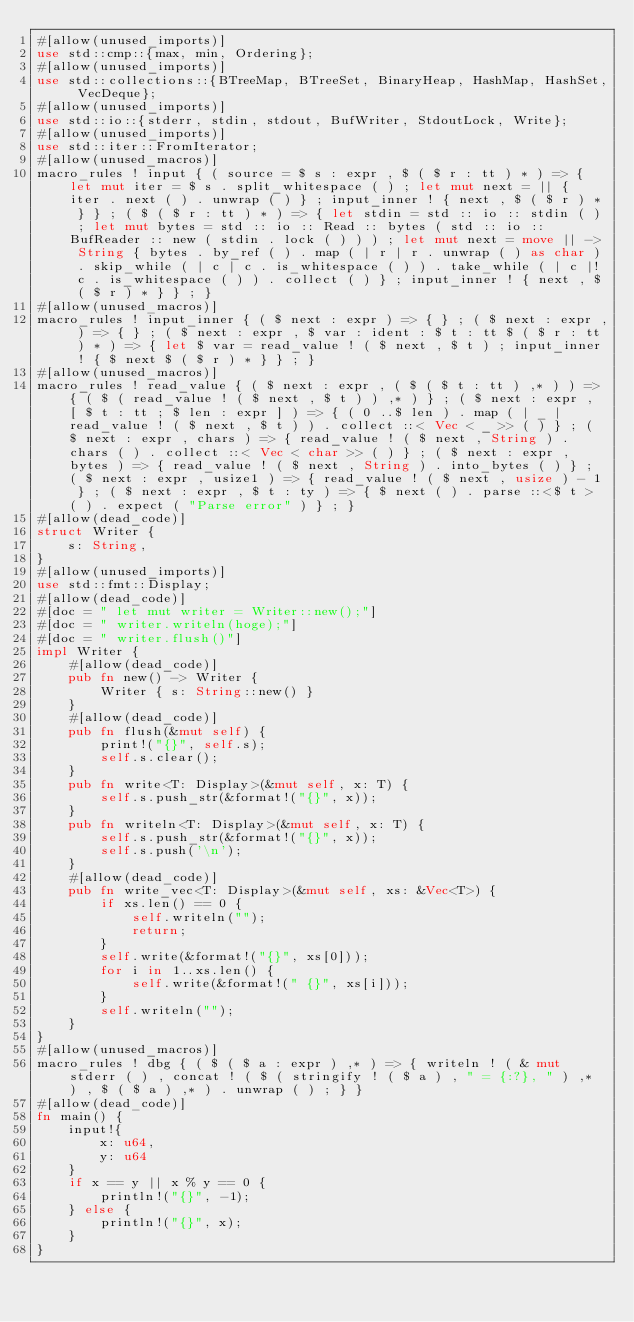<code> <loc_0><loc_0><loc_500><loc_500><_Rust_>#[allow(unused_imports)]
use std::cmp::{max, min, Ordering};
#[allow(unused_imports)]
use std::collections::{BTreeMap, BTreeSet, BinaryHeap, HashMap, HashSet, VecDeque};
#[allow(unused_imports)]
use std::io::{stderr, stdin, stdout, BufWriter, StdoutLock, Write};
#[allow(unused_imports)]
use std::iter::FromIterator;
#[allow(unused_macros)]
macro_rules ! input { ( source = $ s : expr , $ ( $ r : tt ) * ) => { let mut iter = $ s . split_whitespace ( ) ; let mut next = || { iter . next ( ) . unwrap ( ) } ; input_inner ! { next , $ ( $ r ) * } } ; ( $ ( $ r : tt ) * ) => { let stdin = std :: io :: stdin ( ) ; let mut bytes = std :: io :: Read :: bytes ( std :: io :: BufReader :: new ( stdin . lock ( ) ) ) ; let mut next = move || -> String { bytes . by_ref ( ) . map ( | r | r . unwrap ( ) as char ) . skip_while ( | c | c . is_whitespace ( ) ) . take_while ( | c |! c . is_whitespace ( ) ) . collect ( ) } ; input_inner ! { next , $ ( $ r ) * } } ; }
#[allow(unused_macros)]
macro_rules ! input_inner { ( $ next : expr ) => { } ; ( $ next : expr , ) => { } ; ( $ next : expr , $ var : ident : $ t : tt $ ( $ r : tt ) * ) => { let $ var = read_value ! ( $ next , $ t ) ; input_inner ! { $ next $ ( $ r ) * } } ; }
#[allow(unused_macros)]
macro_rules ! read_value { ( $ next : expr , ( $ ( $ t : tt ) ,* ) ) => { ( $ ( read_value ! ( $ next , $ t ) ) ,* ) } ; ( $ next : expr , [ $ t : tt ; $ len : expr ] ) => { ( 0 ..$ len ) . map ( | _ | read_value ! ( $ next , $ t ) ) . collect ::< Vec < _ >> ( ) } ; ( $ next : expr , chars ) => { read_value ! ( $ next , String ) . chars ( ) . collect ::< Vec < char >> ( ) } ; ( $ next : expr , bytes ) => { read_value ! ( $ next , String ) . into_bytes ( ) } ; ( $ next : expr , usize1 ) => { read_value ! ( $ next , usize ) - 1 } ; ( $ next : expr , $ t : ty ) => { $ next ( ) . parse ::<$ t > ( ) . expect ( "Parse error" ) } ; }
#[allow(dead_code)]
struct Writer {
    s: String,
}
#[allow(unused_imports)]
use std::fmt::Display;
#[allow(dead_code)]
#[doc = " let mut writer = Writer::new();"]
#[doc = " writer.writeln(hoge);"]
#[doc = " writer.flush()"]
impl Writer {
    #[allow(dead_code)]
    pub fn new() -> Writer {
        Writer { s: String::new() }
    }
    #[allow(dead_code)]
    pub fn flush(&mut self) {
        print!("{}", self.s);
        self.s.clear();
    }
    pub fn write<T: Display>(&mut self, x: T) {
        self.s.push_str(&format!("{}", x));
    }
    pub fn writeln<T: Display>(&mut self, x: T) {
        self.s.push_str(&format!("{}", x));
        self.s.push('\n');
    }
    #[allow(dead_code)]
    pub fn write_vec<T: Display>(&mut self, xs: &Vec<T>) {
        if xs.len() == 0 {
            self.writeln("");
            return;
        }
        self.write(&format!("{}", xs[0]));
        for i in 1..xs.len() {
            self.write(&format!(" {}", xs[i]));
        }
        self.writeln("");
    }
}
#[allow(unused_macros)]
macro_rules ! dbg { ( $ ( $ a : expr ) ,* ) => { writeln ! ( & mut stderr ( ) , concat ! ( $ ( stringify ! ( $ a ) , " = {:?}, " ) ,* ) , $ ( $ a ) ,* ) . unwrap ( ) ; } }
#[allow(dead_code)]
fn main() {
    input!{
        x: u64,
        y: u64
    }
    if x == y || x % y == 0 {
        println!("{}", -1);
    } else {
        println!("{}", x);
    }
}</code> 